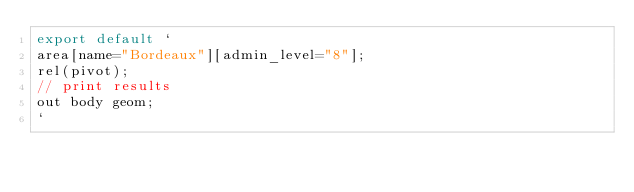Convert code to text. <code><loc_0><loc_0><loc_500><loc_500><_JavaScript_>export default `
area[name="Bordeaux"][admin_level="8"];
rel(pivot);
// print results
out body geom;
`
</code> 